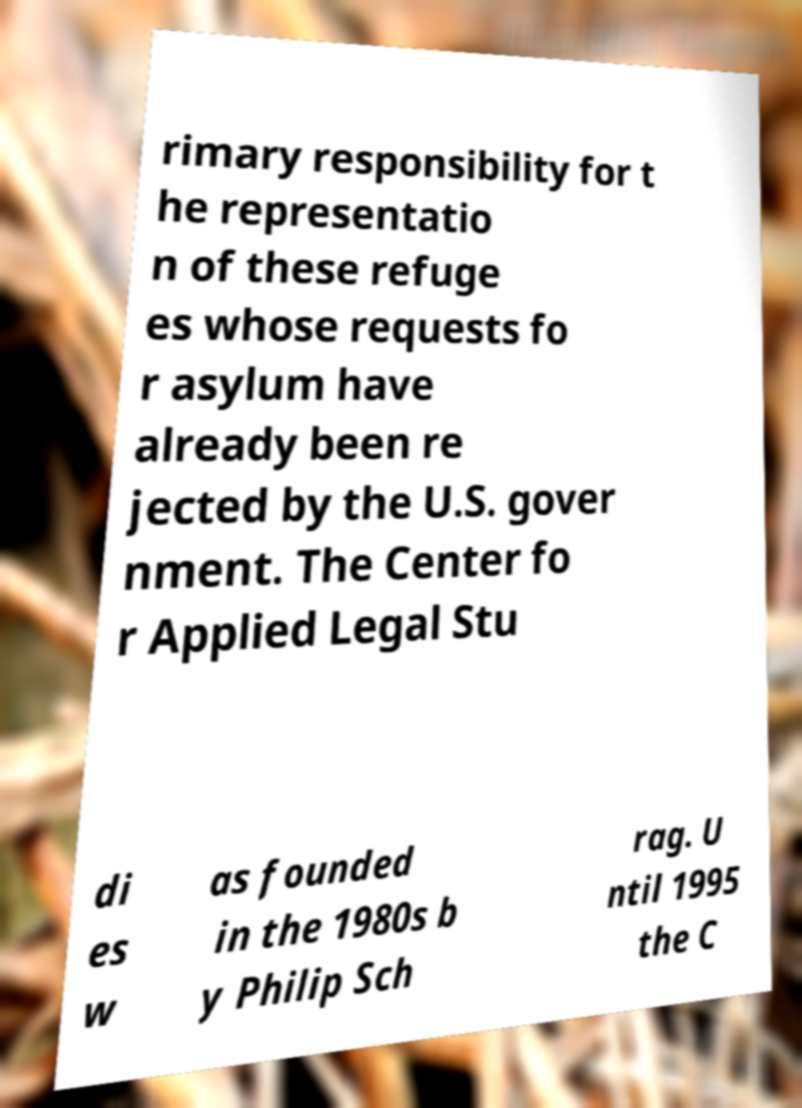I need the written content from this picture converted into text. Can you do that? rimary responsibility for t he representatio n of these refuge es whose requests fo r asylum have already been re jected by the U.S. gover nment. The Center fo r Applied Legal Stu di es w as founded in the 1980s b y Philip Sch rag. U ntil 1995 the C 